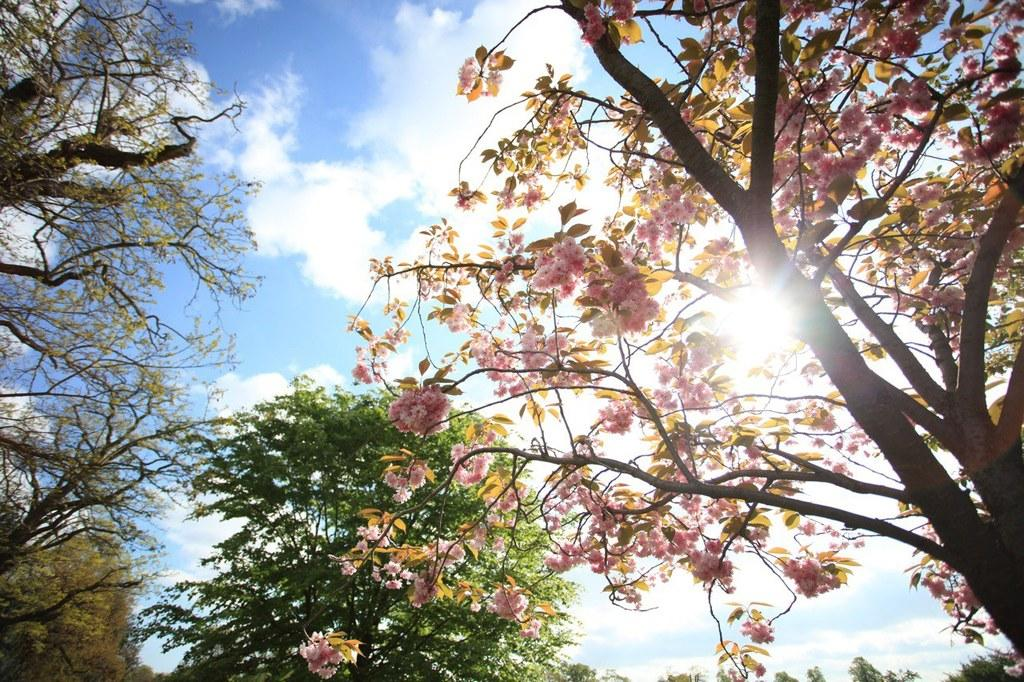What type of vegetation can be seen in the image? There are trees in the image. What part of the natural environment is visible in the image? The sky is visible in the image. What type of insurance policy is being discussed in the image? There is no discussion of insurance policies in the image; it features trees and the sky. How many eggs are visible in the image? There are no eggs present in the image. 